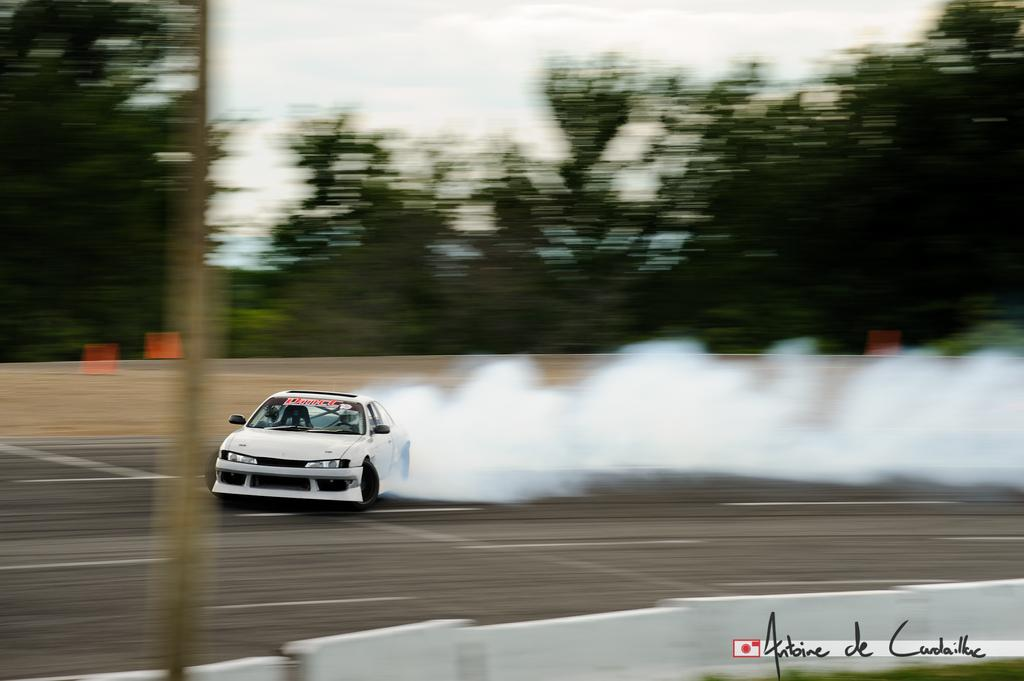What is the main feature of the image? There is a road in the image. What can be seen on the road? There is a white car on the road. What is the car doing? The car is racing. What is visible behind the car? There is smoke behind the car. What can be seen in the background of the image? There are trees and the sky visible in the background of the image. How many frogs are jumping across the road in the image? There are no frogs present in the image; it features a white car racing on the road. What type of tooth is visible in the image? There is no tooth present in the image. 